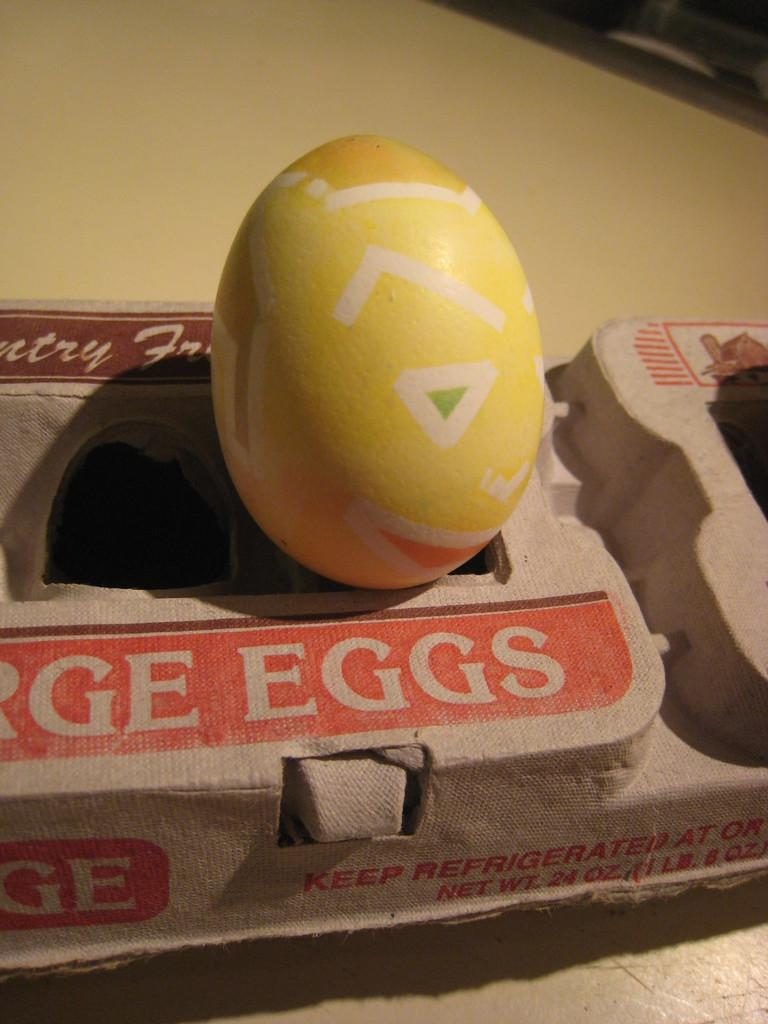What color is the egg in the image? The egg in the image is yellow. Where is the egg located? The egg is on an egg box. What is the egg box placed on? The egg box is on a surface. What type of bulb is illuminating the egg in the image? There is no bulb present in the image; it only shows a yellow egg on an egg box. 